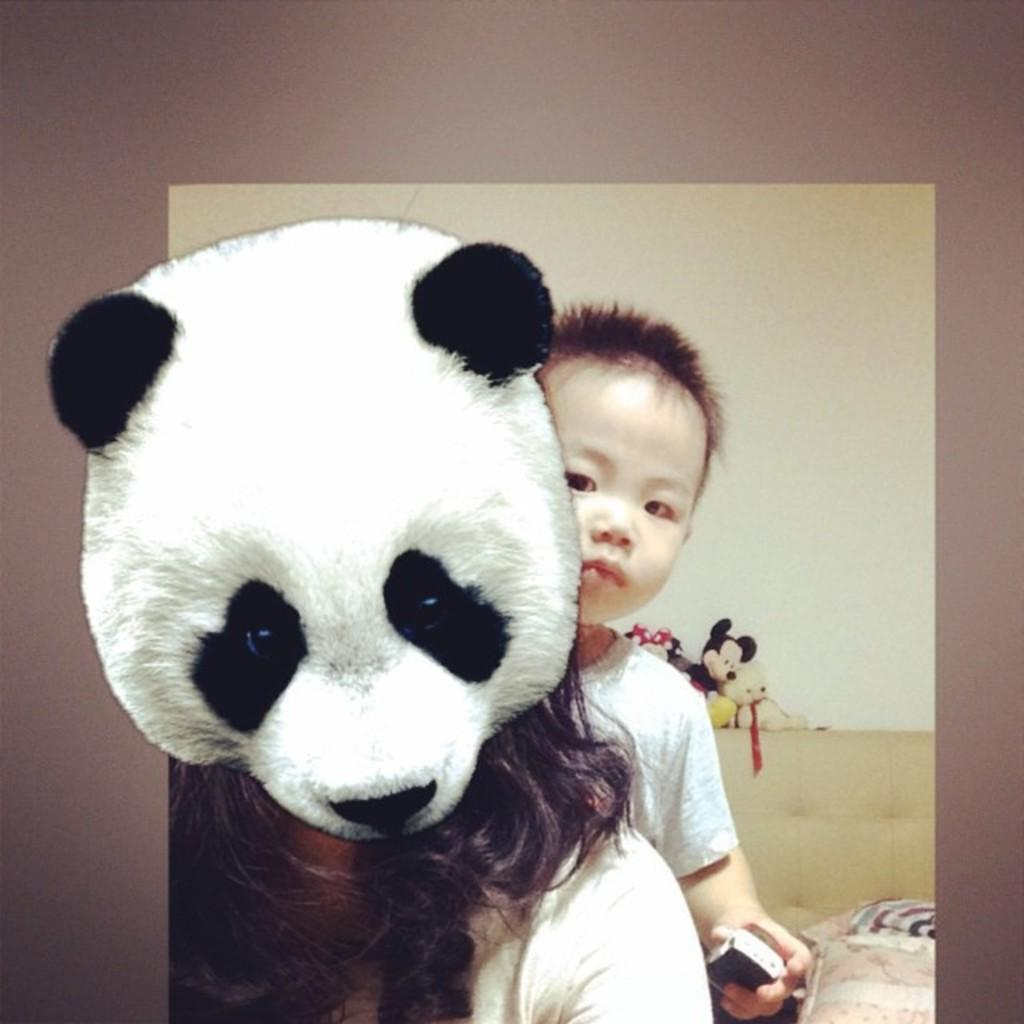What is one of the main objects in the image? There is a wall in the image. What is another object that can be seen in the image? There is a screen in the image. Can you describe any toys present in the image? There is a teddy bear toy in the image. What is the boy in the image holding? The boy is holding a remote in the image. What is displayed on the screen? The screen displays toys and the sky. What type of skirt is the airplane wearing in the image? There is no airplane or skirt present in the image. What error can be seen on the screen? There is no error mentioned or visible in the image. 